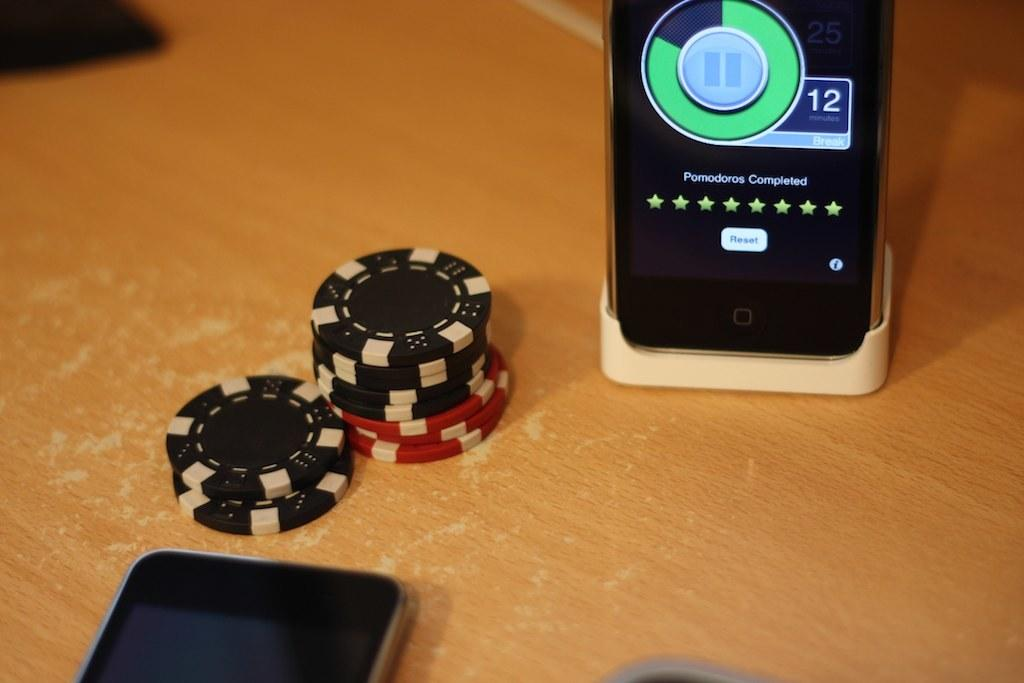<image>
Describe the image concisely. A smart phone reads Pomodoros Completed on a wooden table. 